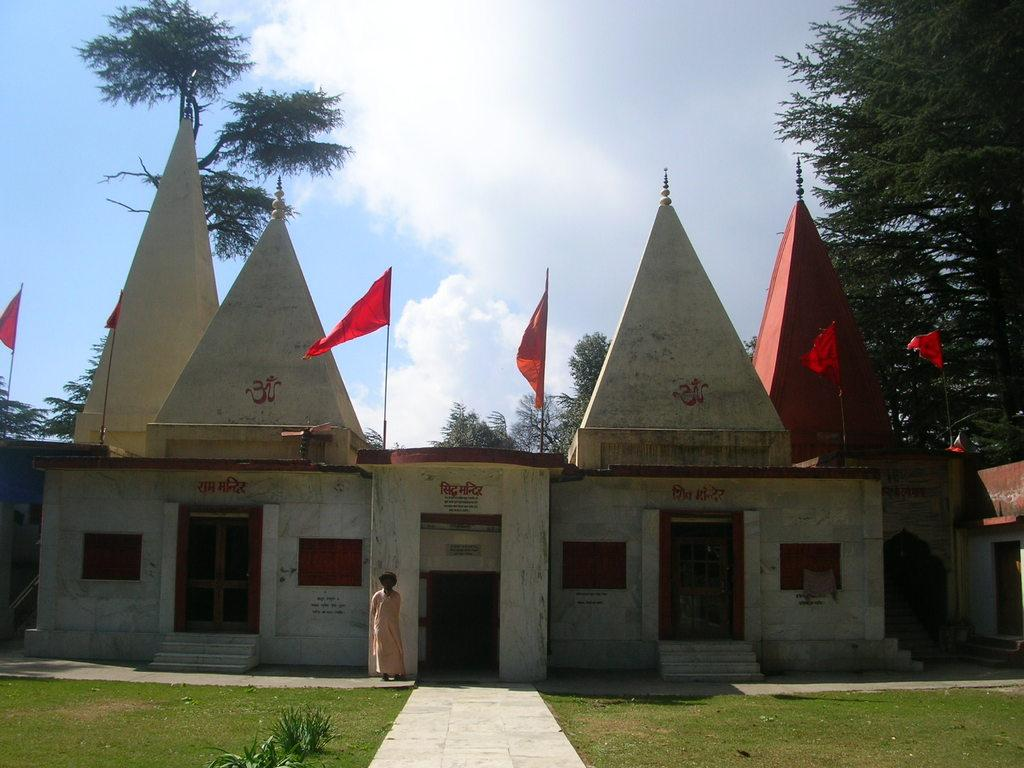What type of structure is visible in the image? There is a building in the image. What can be seen flying or hanging near the building? There are flags in the image. What type of natural environment is present in the image? There is grass, plants, and trees in the image. Who or what is present in the image? There is a person in the image. What is the weather like in the image? The sky is cloudy in the image. What is written on the walls of the building? Something is written on the walls of the building. What type of bird is shaking a jar in the image? There is no bird or jar present in the image. 